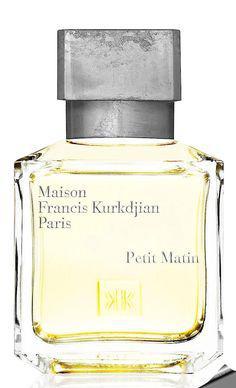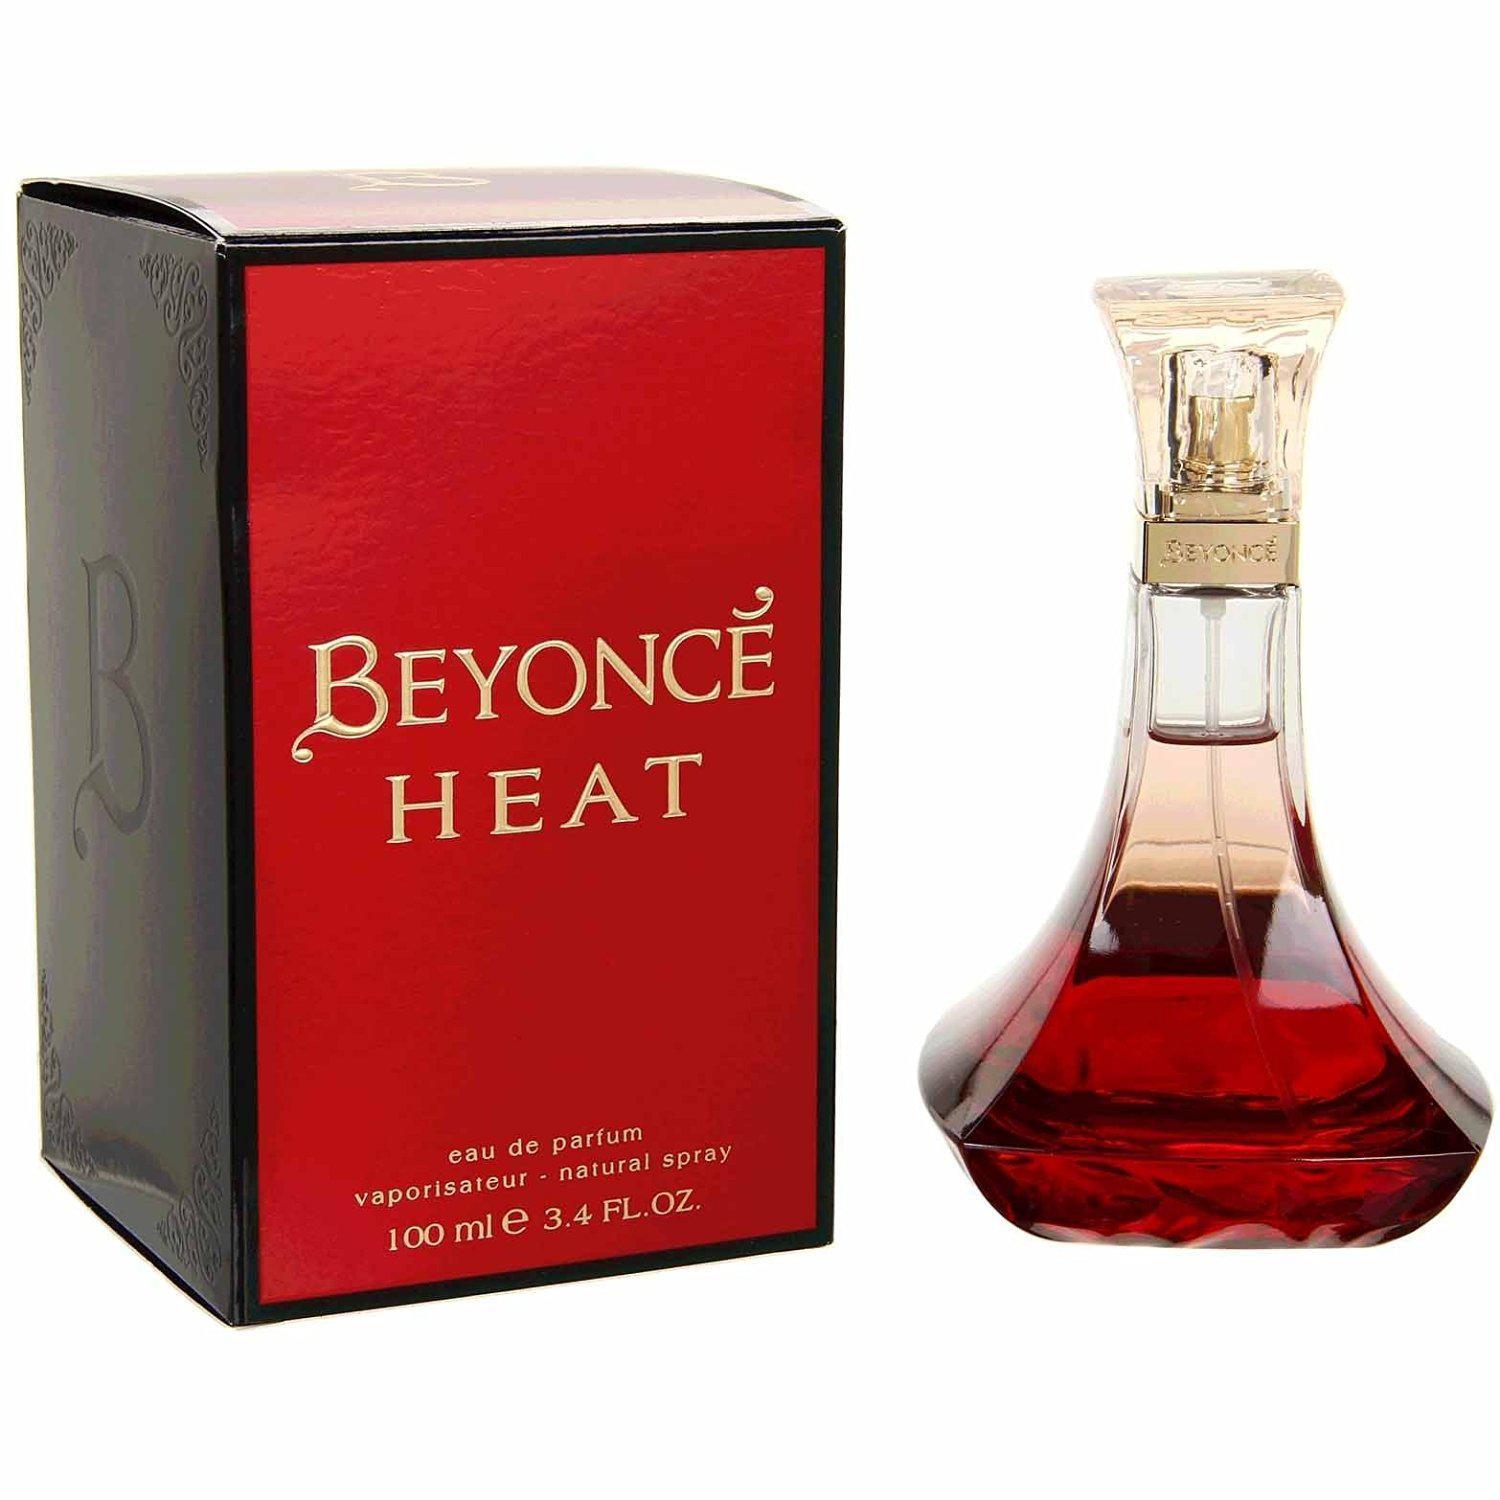The first image is the image on the left, the second image is the image on the right. Evaluate the accuracy of this statement regarding the images: "There is a single glass bottle of perfume next to it's box with a clear cap". Is it true? Answer yes or no. Yes. The first image is the image on the left, the second image is the image on the right. Analyze the images presented: Is the assertion "One image shows exactly one fragrance bottle next to its box but not overlapping it." valid? Answer yes or no. Yes. 